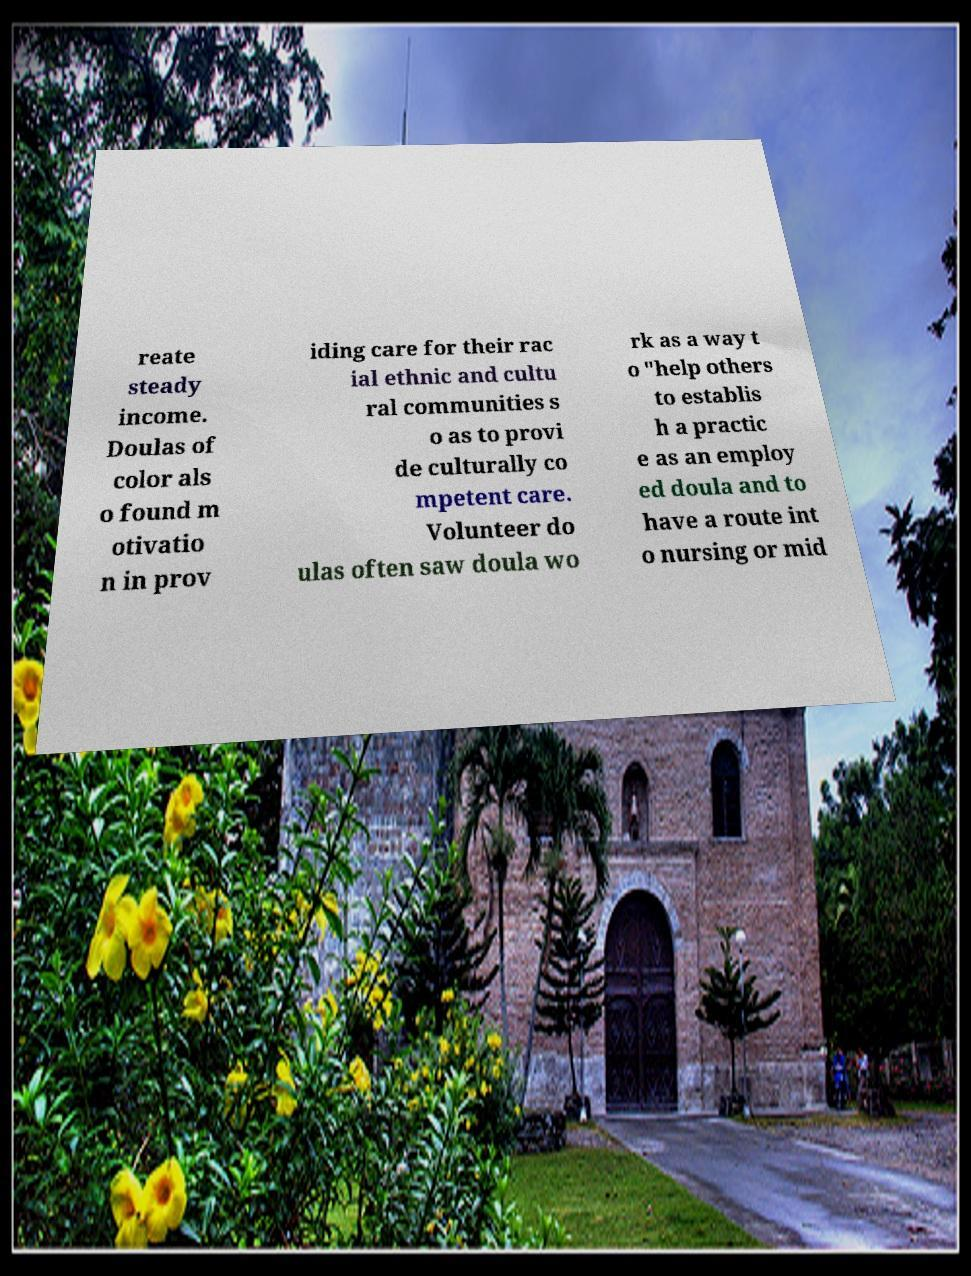Could you assist in decoding the text presented in this image and type it out clearly? reate steady income. Doulas of color als o found m otivatio n in prov iding care for their rac ial ethnic and cultu ral communities s o as to provi de culturally co mpetent care. Volunteer do ulas often saw doula wo rk as a way t o "help others to establis h a practic e as an employ ed doula and to have a route int o nursing or mid 